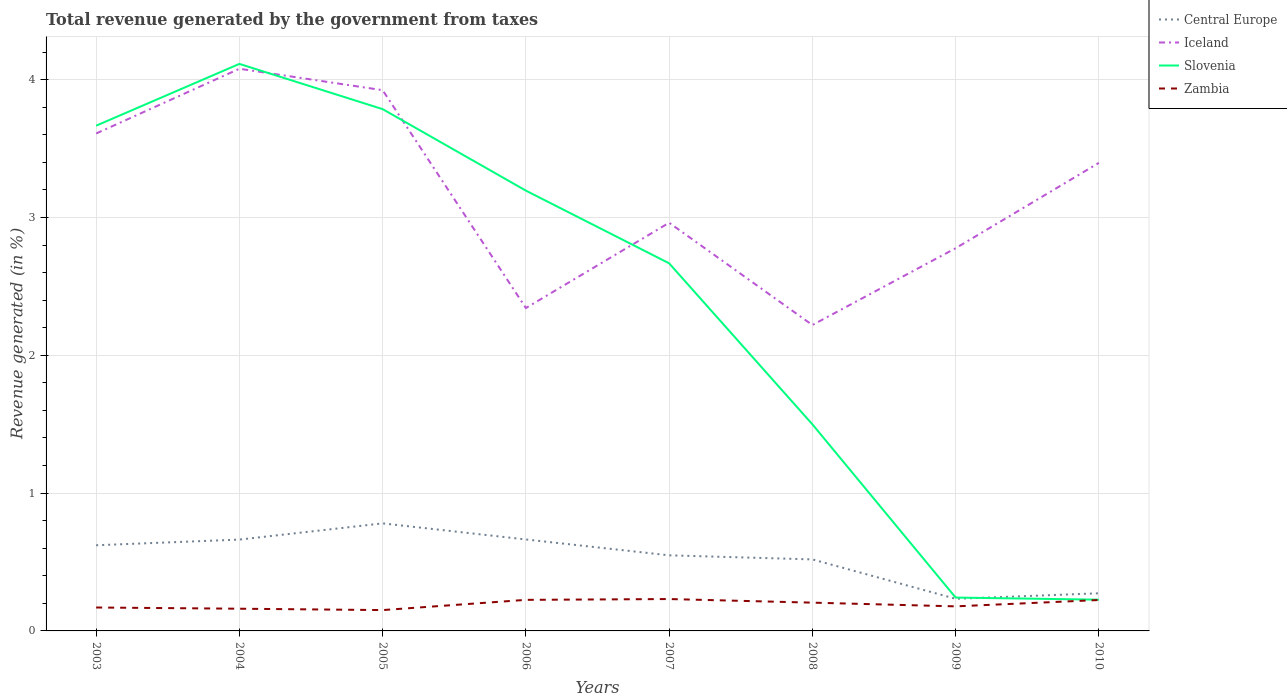Across all years, what is the maximum total revenue generated in Slovenia?
Provide a succinct answer. 0.23. What is the total total revenue generated in Iceland in the graph?
Your response must be concise. -1.05. What is the difference between the highest and the second highest total revenue generated in Slovenia?
Ensure brevity in your answer.  3.89. Is the total revenue generated in Slovenia strictly greater than the total revenue generated in Zambia over the years?
Make the answer very short. No. How many lines are there?
Your answer should be very brief. 4. What is the difference between two consecutive major ticks on the Y-axis?
Ensure brevity in your answer.  1. Does the graph contain grids?
Give a very brief answer. Yes. How many legend labels are there?
Offer a terse response. 4. How are the legend labels stacked?
Provide a succinct answer. Vertical. What is the title of the graph?
Ensure brevity in your answer.  Total revenue generated by the government from taxes. What is the label or title of the X-axis?
Provide a short and direct response. Years. What is the label or title of the Y-axis?
Give a very brief answer. Revenue generated (in %). What is the Revenue generated (in %) of Central Europe in 2003?
Your response must be concise. 0.62. What is the Revenue generated (in %) of Iceland in 2003?
Ensure brevity in your answer.  3.61. What is the Revenue generated (in %) in Slovenia in 2003?
Ensure brevity in your answer.  3.67. What is the Revenue generated (in %) in Zambia in 2003?
Give a very brief answer. 0.17. What is the Revenue generated (in %) of Central Europe in 2004?
Make the answer very short. 0.66. What is the Revenue generated (in %) of Iceland in 2004?
Give a very brief answer. 4.08. What is the Revenue generated (in %) in Slovenia in 2004?
Ensure brevity in your answer.  4.11. What is the Revenue generated (in %) of Zambia in 2004?
Offer a very short reply. 0.16. What is the Revenue generated (in %) in Central Europe in 2005?
Your answer should be compact. 0.78. What is the Revenue generated (in %) in Iceland in 2005?
Make the answer very short. 3.92. What is the Revenue generated (in %) of Slovenia in 2005?
Provide a short and direct response. 3.79. What is the Revenue generated (in %) of Zambia in 2005?
Make the answer very short. 0.15. What is the Revenue generated (in %) in Central Europe in 2006?
Keep it short and to the point. 0.66. What is the Revenue generated (in %) of Iceland in 2006?
Ensure brevity in your answer.  2.34. What is the Revenue generated (in %) in Slovenia in 2006?
Provide a short and direct response. 3.19. What is the Revenue generated (in %) of Zambia in 2006?
Your response must be concise. 0.23. What is the Revenue generated (in %) of Central Europe in 2007?
Offer a very short reply. 0.55. What is the Revenue generated (in %) of Iceland in 2007?
Offer a very short reply. 2.96. What is the Revenue generated (in %) in Slovenia in 2007?
Your response must be concise. 2.67. What is the Revenue generated (in %) in Zambia in 2007?
Offer a terse response. 0.23. What is the Revenue generated (in %) in Central Europe in 2008?
Keep it short and to the point. 0.52. What is the Revenue generated (in %) in Iceland in 2008?
Make the answer very short. 2.22. What is the Revenue generated (in %) of Slovenia in 2008?
Provide a short and direct response. 1.5. What is the Revenue generated (in %) in Zambia in 2008?
Your response must be concise. 0.21. What is the Revenue generated (in %) in Central Europe in 2009?
Ensure brevity in your answer.  0.23. What is the Revenue generated (in %) of Iceland in 2009?
Offer a very short reply. 2.78. What is the Revenue generated (in %) of Slovenia in 2009?
Give a very brief answer. 0.24. What is the Revenue generated (in %) in Zambia in 2009?
Make the answer very short. 0.18. What is the Revenue generated (in %) in Central Europe in 2010?
Your answer should be very brief. 0.27. What is the Revenue generated (in %) in Iceland in 2010?
Ensure brevity in your answer.  3.4. What is the Revenue generated (in %) of Slovenia in 2010?
Keep it short and to the point. 0.23. What is the Revenue generated (in %) of Zambia in 2010?
Keep it short and to the point. 0.22. Across all years, what is the maximum Revenue generated (in %) in Central Europe?
Offer a terse response. 0.78. Across all years, what is the maximum Revenue generated (in %) in Iceland?
Ensure brevity in your answer.  4.08. Across all years, what is the maximum Revenue generated (in %) in Slovenia?
Your answer should be very brief. 4.11. Across all years, what is the maximum Revenue generated (in %) in Zambia?
Your answer should be very brief. 0.23. Across all years, what is the minimum Revenue generated (in %) in Central Europe?
Keep it short and to the point. 0.23. Across all years, what is the minimum Revenue generated (in %) of Iceland?
Ensure brevity in your answer.  2.22. Across all years, what is the minimum Revenue generated (in %) in Slovenia?
Your answer should be very brief. 0.23. Across all years, what is the minimum Revenue generated (in %) of Zambia?
Make the answer very short. 0.15. What is the total Revenue generated (in %) in Central Europe in the graph?
Offer a very short reply. 4.3. What is the total Revenue generated (in %) of Iceland in the graph?
Offer a very short reply. 25.31. What is the total Revenue generated (in %) in Slovenia in the graph?
Ensure brevity in your answer.  19.4. What is the total Revenue generated (in %) in Zambia in the graph?
Your answer should be compact. 1.55. What is the difference between the Revenue generated (in %) in Central Europe in 2003 and that in 2004?
Make the answer very short. -0.04. What is the difference between the Revenue generated (in %) in Iceland in 2003 and that in 2004?
Offer a very short reply. -0.47. What is the difference between the Revenue generated (in %) in Slovenia in 2003 and that in 2004?
Your answer should be compact. -0.45. What is the difference between the Revenue generated (in %) in Zambia in 2003 and that in 2004?
Give a very brief answer. 0.01. What is the difference between the Revenue generated (in %) of Central Europe in 2003 and that in 2005?
Make the answer very short. -0.16. What is the difference between the Revenue generated (in %) in Iceland in 2003 and that in 2005?
Offer a terse response. -0.31. What is the difference between the Revenue generated (in %) of Slovenia in 2003 and that in 2005?
Provide a succinct answer. -0.12. What is the difference between the Revenue generated (in %) of Zambia in 2003 and that in 2005?
Give a very brief answer. 0.02. What is the difference between the Revenue generated (in %) in Central Europe in 2003 and that in 2006?
Offer a terse response. -0.04. What is the difference between the Revenue generated (in %) in Iceland in 2003 and that in 2006?
Your answer should be compact. 1.27. What is the difference between the Revenue generated (in %) in Slovenia in 2003 and that in 2006?
Your response must be concise. 0.47. What is the difference between the Revenue generated (in %) in Zambia in 2003 and that in 2006?
Make the answer very short. -0.06. What is the difference between the Revenue generated (in %) in Central Europe in 2003 and that in 2007?
Keep it short and to the point. 0.07. What is the difference between the Revenue generated (in %) of Iceland in 2003 and that in 2007?
Provide a short and direct response. 0.65. What is the difference between the Revenue generated (in %) of Slovenia in 2003 and that in 2007?
Your answer should be very brief. 1. What is the difference between the Revenue generated (in %) in Zambia in 2003 and that in 2007?
Your answer should be compact. -0.06. What is the difference between the Revenue generated (in %) in Central Europe in 2003 and that in 2008?
Ensure brevity in your answer.  0.1. What is the difference between the Revenue generated (in %) of Iceland in 2003 and that in 2008?
Make the answer very short. 1.39. What is the difference between the Revenue generated (in %) in Slovenia in 2003 and that in 2008?
Provide a succinct answer. 2.17. What is the difference between the Revenue generated (in %) in Zambia in 2003 and that in 2008?
Offer a very short reply. -0.04. What is the difference between the Revenue generated (in %) of Central Europe in 2003 and that in 2009?
Offer a very short reply. 0.39. What is the difference between the Revenue generated (in %) of Iceland in 2003 and that in 2009?
Give a very brief answer. 0.83. What is the difference between the Revenue generated (in %) in Slovenia in 2003 and that in 2009?
Make the answer very short. 3.42. What is the difference between the Revenue generated (in %) of Zambia in 2003 and that in 2009?
Keep it short and to the point. -0.01. What is the difference between the Revenue generated (in %) in Central Europe in 2003 and that in 2010?
Give a very brief answer. 0.35. What is the difference between the Revenue generated (in %) of Iceland in 2003 and that in 2010?
Your answer should be very brief. 0.21. What is the difference between the Revenue generated (in %) in Slovenia in 2003 and that in 2010?
Your response must be concise. 3.44. What is the difference between the Revenue generated (in %) in Zambia in 2003 and that in 2010?
Your answer should be compact. -0.05. What is the difference between the Revenue generated (in %) of Central Europe in 2004 and that in 2005?
Make the answer very short. -0.12. What is the difference between the Revenue generated (in %) in Iceland in 2004 and that in 2005?
Your answer should be very brief. 0.16. What is the difference between the Revenue generated (in %) in Slovenia in 2004 and that in 2005?
Offer a very short reply. 0.33. What is the difference between the Revenue generated (in %) in Zambia in 2004 and that in 2005?
Your response must be concise. 0.01. What is the difference between the Revenue generated (in %) in Central Europe in 2004 and that in 2006?
Offer a terse response. -0. What is the difference between the Revenue generated (in %) of Iceland in 2004 and that in 2006?
Provide a short and direct response. 1.74. What is the difference between the Revenue generated (in %) of Slovenia in 2004 and that in 2006?
Your response must be concise. 0.92. What is the difference between the Revenue generated (in %) of Zambia in 2004 and that in 2006?
Offer a terse response. -0.06. What is the difference between the Revenue generated (in %) of Central Europe in 2004 and that in 2007?
Give a very brief answer. 0.11. What is the difference between the Revenue generated (in %) of Iceland in 2004 and that in 2007?
Provide a short and direct response. 1.12. What is the difference between the Revenue generated (in %) of Slovenia in 2004 and that in 2007?
Keep it short and to the point. 1.45. What is the difference between the Revenue generated (in %) in Zambia in 2004 and that in 2007?
Your answer should be very brief. -0.07. What is the difference between the Revenue generated (in %) of Central Europe in 2004 and that in 2008?
Make the answer very short. 0.14. What is the difference between the Revenue generated (in %) of Iceland in 2004 and that in 2008?
Offer a very short reply. 1.86. What is the difference between the Revenue generated (in %) of Slovenia in 2004 and that in 2008?
Make the answer very short. 2.62. What is the difference between the Revenue generated (in %) of Zambia in 2004 and that in 2008?
Make the answer very short. -0.04. What is the difference between the Revenue generated (in %) of Central Europe in 2004 and that in 2009?
Your response must be concise. 0.43. What is the difference between the Revenue generated (in %) of Iceland in 2004 and that in 2009?
Give a very brief answer. 1.3. What is the difference between the Revenue generated (in %) of Slovenia in 2004 and that in 2009?
Make the answer very short. 3.87. What is the difference between the Revenue generated (in %) of Zambia in 2004 and that in 2009?
Provide a succinct answer. -0.02. What is the difference between the Revenue generated (in %) in Central Europe in 2004 and that in 2010?
Your response must be concise. 0.39. What is the difference between the Revenue generated (in %) in Iceland in 2004 and that in 2010?
Offer a very short reply. 0.68. What is the difference between the Revenue generated (in %) in Slovenia in 2004 and that in 2010?
Offer a terse response. 3.89. What is the difference between the Revenue generated (in %) of Zambia in 2004 and that in 2010?
Keep it short and to the point. -0.06. What is the difference between the Revenue generated (in %) of Central Europe in 2005 and that in 2006?
Ensure brevity in your answer.  0.12. What is the difference between the Revenue generated (in %) of Iceland in 2005 and that in 2006?
Your answer should be very brief. 1.58. What is the difference between the Revenue generated (in %) of Slovenia in 2005 and that in 2006?
Provide a short and direct response. 0.59. What is the difference between the Revenue generated (in %) in Zambia in 2005 and that in 2006?
Your response must be concise. -0.07. What is the difference between the Revenue generated (in %) in Central Europe in 2005 and that in 2007?
Provide a short and direct response. 0.23. What is the difference between the Revenue generated (in %) of Iceland in 2005 and that in 2007?
Your answer should be very brief. 0.96. What is the difference between the Revenue generated (in %) of Slovenia in 2005 and that in 2007?
Provide a succinct answer. 1.12. What is the difference between the Revenue generated (in %) of Zambia in 2005 and that in 2007?
Provide a short and direct response. -0.08. What is the difference between the Revenue generated (in %) of Central Europe in 2005 and that in 2008?
Provide a short and direct response. 0.26. What is the difference between the Revenue generated (in %) of Iceland in 2005 and that in 2008?
Ensure brevity in your answer.  1.7. What is the difference between the Revenue generated (in %) of Slovenia in 2005 and that in 2008?
Give a very brief answer. 2.29. What is the difference between the Revenue generated (in %) of Zambia in 2005 and that in 2008?
Make the answer very short. -0.05. What is the difference between the Revenue generated (in %) of Central Europe in 2005 and that in 2009?
Your response must be concise. 0.55. What is the difference between the Revenue generated (in %) in Iceland in 2005 and that in 2009?
Your response must be concise. 1.15. What is the difference between the Revenue generated (in %) in Slovenia in 2005 and that in 2009?
Your answer should be very brief. 3.54. What is the difference between the Revenue generated (in %) of Zambia in 2005 and that in 2009?
Your answer should be compact. -0.03. What is the difference between the Revenue generated (in %) in Central Europe in 2005 and that in 2010?
Ensure brevity in your answer.  0.51. What is the difference between the Revenue generated (in %) in Iceland in 2005 and that in 2010?
Keep it short and to the point. 0.53. What is the difference between the Revenue generated (in %) in Slovenia in 2005 and that in 2010?
Make the answer very short. 3.56. What is the difference between the Revenue generated (in %) in Zambia in 2005 and that in 2010?
Provide a short and direct response. -0.07. What is the difference between the Revenue generated (in %) of Central Europe in 2006 and that in 2007?
Your answer should be compact. 0.12. What is the difference between the Revenue generated (in %) of Iceland in 2006 and that in 2007?
Ensure brevity in your answer.  -0.62. What is the difference between the Revenue generated (in %) of Slovenia in 2006 and that in 2007?
Give a very brief answer. 0.53. What is the difference between the Revenue generated (in %) in Zambia in 2006 and that in 2007?
Your response must be concise. -0.01. What is the difference between the Revenue generated (in %) of Central Europe in 2006 and that in 2008?
Your answer should be compact. 0.14. What is the difference between the Revenue generated (in %) in Iceland in 2006 and that in 2008?
Your answer should be very brief. 0.12. What is the difference between the Revenue generated (in %) in Slovenia in 2006 and that in 2008?
Your answer should be very brief. 1.7. What is the difference between the Revenue generated (in %) of Zambia in 2006 and that in 2008?
Give a very brief answer. 0.02. What is the difference between the Revenue generated (in %) of Central Europe in 2006 and that in 2009?
Offer a very short reply. 0.43. What is the difference between the Revenue generated (in %) of Iceland in 2006 and that in 2009?
Your response must be concise. -0.43. What is the difference between the Revenue generated (in %) in Slovenia in 2006 and that in 2009?
Offer a very short reply. 2.95. What is the difference between the Revenue generated (in %) in Zambia in 2006 and that in 2009?
Offer a very short reply. 0.05. What is the difference between the Revenue generated (in %) of Central Europe in 2006 and that in 2010?
Your answer should be compact. 0.39. What is the difference between the Revenue generated (in %) of Iceland in 2006 and that in 2010?
Make the answer very short. -1.05. What is the difference between the Revenue generated (in %) in Slovenia in 2006 and that in 2010?
Give a very brief answer. 2.97. What is the difference between the Revenue generated (in %) of Zambia in 2006 and that in 2010?
Provide a short and direct response. 0. What is the difference between the Revenue generated (in %) of Central Europe in 2007 and that in 2008?
Your answer should be very brief. 0.03. What is the difference between the Revenue generated (in %) of Iceland in 2007 and that in 2008?
Give a very brief answer. 0.74. What is the difference between the Revenue generated (in %) in Slovenia in 2007 and that in 2008?
Keep it short and to the point. 1.17. What is the difference between the Revenue generated (in %) in Zambia in 2007 and that in 2008?
Give a very brief answer. 0.03. What is the difference between the Revenue generated (in %) of Central Europe in 2007 and that in 2009?
Give a very brief answer. 0.32. What is the difference between the Revenue generated (in %) of Iceland in 2007 and that in 2009?
Your answer should be very brief. 0.18. What is the difference between the Revenue generated (in %) in Slovenia in 2007 and that in 2009?
Give a very brief answer. 2.43. What is the difference between the Revenue generated (in %) of Zambia in 2007 and that in 2009?
Ensure brevity in your answer.  0.05. What is the difference between the Revenue generated (in %) in Central Europe in 2007 and that in 2010?
Your response must be concise. 0.28. What is the difference between the Revenue generated (in %) in Iceland in 2007 and that in 2010?
Make the answer very short. -0.43. What is the difference between the Revenue generated (in %) of Slovenia in 2007 and that in 2010?
Your answer should be very brief. 2.44. What is the difference between the Revenue generated (in %) in Zambia in 2007 and that in 2010?
Offer a terse response. 0.01. What is the difference between the Revenue generated (in %) in Central Europe in 2008 and that in 2009?
Your response must be concise. 0.29. What is the difference between the Revenue generated (in %) of Iceland in 2008 and that in 2009?
Give a very brief answer. -0.56. What is the difference between the Revenue generated (in %) of Slovenia in 2008 and that in 2009?
Your response must be concise. 1.26. What is the difference between the Revenue generated (in %) of Zambia in 2008 and that in 2009?
Ensure brevity in your answer.  0.03. What is the difference between the Revenue generated (in %) in Central Europe in 2008 and that in 2010?
Offer a very short reply. 0.25. What is the difference between the Revenue generated (in %) in Iceland in 2008 and that in 2010?
Ensure brevity in your answer.  -1.18. What is the difference between the Revenue generated (in %) in Slovenia in 2008 and that in 2010?
Offer a terse response. 1.27. What is the difference between the Revenue generated (in %) in Zambia in 2008 and that in 2010?
Give a very brief answer. -0.02. What is the difference between the Revenue generated (in %) of Central Europe in 2009 and that in 2010?
Your answer should be very brief. -0.04. What is the difference between the Revenue generated (in %) of Iceland in 2009 and that in 2010?
Your answer should be very brief. -0.62. What is the difference between the Revenue generated (in %) of Slovenia in 2009 and that in 2010?
Offer a terse response. 0.02. What is the difference between the Revenue generated (in %) of Zambia in 2009 and that in 2010?
Keep it short and to the point. -0.05. What is the difference between the Revenue generated (in %) of Central Europe in 2003 and the Revenue generated (in %) of Iceland in 2004?
Give a very brief answer. -3.46. What is the difference between the Revenue generated (in %) of Central Europe in 2003 and the Revenue generated (in %) of Slovenia in 2004?
Offer a very short reply. -3.49. What is the difference between the Revenue generated (in %) of Central Europe in 2003 and the Revenue generated (in %) of Zambia in 2004?
Offer a very short reply. 0.46. What is the difference between the Revenue generated (in %) of Iceland in 2003 and the Revenue generated (in %) of Slovenia in 2004?
Provide a succinct answer. -0.51. What is the difference between the Revenue generated (in %) in Iceland in 2003 and the Revenue generated (in %) in Zambia in 2004?
Your answer should be compact. 3.45. What is the difference between the Revenue generated (in %) of Slovenia in 2003 and the Revenue generated (in %) of Zambia in 2004?
Offer a terse response. 3.5. What is the difference between the Revenue generated (in %) of Central Europe in 2003 and the Revenue generated (in %) of Iceland in 2005?
Keep it short and to the point. -3.3. What is the difference between the Revenue generated (in %) of Central Europe in 2003 and the Revenue generated (in %) of Slovenia in 2005?
Provide a short and direct response. -3.16. What is the difference between the Revenue generated (in %) of Central Europe in 2003 and the Revenue generated (in %) of Zambia in 2005?
Offer a very short reply. 0.47. What is the difference between the Revenue generated (in %) in Iceland in 2003 and the Revenue generated (in %) in Slovenia in 2005?
Give a very brief answer. -0.18. What is the difference between the Revenue generated (in %) in Iceland in 2003 and the Revenue generated (in %) in Zambia in 2005?
Ensure brevity in your answer.  3.46. What is the difference between the Revenue generated (in %) of Slovenia in 2003 and the Revenue generated (in %) of Zambia in 2005?
Provide a succinct answer. 3.51. What is the difference between the Revenue generated (in %) in Central Europe in 2003 and the Revenue generated (in %) in Iceland in 2006?
Provide a short and direct response. -1.72. What is the difference between the Revenue generated (in %) of Central Europe in 2003 and the Revenue generated (in %) of Slovenia in 2006?
Make the answer very short. -2.57. What is the difference between the Revenue generated (in %) in Central Europe in 2003 and the Revenue generated (in %) in Zambia in 2006?
Keep it short and to the point. 0.4. What is the difference between the Revenue generated (in %) in Iceland in 2003 and the Revenue generated (in %) in Slovenia in 2006?
Provide a short and direct response. 0.41. What is the difference between the Revenue generated (in %) in Iceland in 2003 and the Revenue generated (in %) in Zambia in 2006?
Keep it short and to the point. 3.38. What is the difference between the Revenue generated (in %) of Slovenia in 2003 and the Revenue generated (in %) of Zambia in 2006?
Offer a terse response. 3.44. What is the difference between the Revenue generated (in %) of Central Europe in 2003 and the Revenue generated (in %) of Iceland in 2007?
Your answer should be compact. -2.34. What is the difference between the Revenue generated (in %) in Central Europe in 2003 and the Revenue generated (in %) in Slovenia in 2007?
Make the answer very short. -2.05. What is the difference between the Revenue generated (in %) of Central Europe in 2003 and the Revenue generated (in %) of Zambia in 2007?
Ensure brevity in your answer.  0.39. What is the difference between the Revenue generated (in %) of Iceland in 2003 and the Revenue generated (in %) of Slovenia in 2007?
Your response must be concise. 0.94. What is the difference between the Revenue generated (in %) in Iceland in 2003 and the Revenue generated (in %) in Zambia in 2007?
Your answer should be very brief. 3.38. What is the difference between the Revenue generated (in %) of Slovenia in 2003 and the Revenue generated (in %) of Zambia in 2007?
Keep it short and to the point. 3.43. What is the difference between the Revenue generated (in %) in Central Europe in 2003 and the Revenue generated (in %) in Iceland in 2008?
Give a very brief answer. -1.6. What is the difference between the Revenue generated (in %) of Central Europe in 2003 and the Revenue generated (in %) of Slovenia in 2008?
Your answer should be compact. -0.88. What is the difference between the Revenue generated (in %) in Central Europe in 2003 and the Revenue generated (in %) in Zambia in 2008?
Offer a terse response. 0.42. What is the difference between the Revenue generated (in %) of Iceland in 2003 and the Revenue generated (in %) of Slovenia in 2008?
Offer a terse response. 2.11. What is the difference between the Revenue generated (in %) in Iceland in 2003 and the Revenue generated (in %) in Zambia in 2008?
Your response must be concise. 3.4. What is the difference between the Revenue generated (in %) of Slovenia in 2003 and the Revenue generated (in %) of Zambia in 2008?
Provide a succinct answer. 3.46. What is the difference between the Revenue generated (in %) in Central Europe in 2003 and the Revenue generated (in %) in Iceland in 2009?
Ensure brevity in your answer.  -2.15. What is the difference between the Revenue generated (in %) in Central Europe in 2003 and the Revenue generated (in %) in Slovenia in 2009?
Your answer should be very brief. 0.38. What is the difference between the Revenue generated (in %) in Central Europe in 2003 and the Revenue generated (in %) in Zambia in 2009?
Your response must be concise. 0.44. What is the difference between the Revenue generated (in %) in Iceland in 2003 and the Revenue generated (in %) in Slovenia in 2009?
Your answer should be compact. 3.37. What is the difference between the Revenue generated (in %) of Iceland in 2003 and the Revenue generated (in %) of Zambia in 2009?
Your answer should be very brief. 3.43. What is the difference between the Revenue generated (in %) in Slovenia in 2003 and the Revenue generated (in %) in Zambia in 2009?
Ensure brevity in your answer.  3.49. What is the difference between the Revenue generated (in %) in Central Europe in 2003 and the Revenue generated (in %) in Iceland in 2010?
Offer a very short reply. -2.77. What is the difference between the Revenue generated (in %) of Central Europe in 2003 and the Revenue generated (in %) of Slovenia in 2010?
Ensure brevity in your answer.  0.39. What is the difference between the Revenue generated (in %) in Central Europe in 2003 and the Revenue generated (in %) in Zambia in 2010?
Offer a very short reply. 0.4. What is the difference between the Revenue generated (in %) of Iceland in 2003 and the Revenue generated (in %) of Slovenia in 2010?
Your answer should be compact. 3.38. What is the difference between the Revenue generated (in %) in Iceland in 2003 and the Revenue generated (in %) in Zambia in 2010?
Give a very brief answer. 3.38. What is the difference between the Revenue generated (in %) in Slovenia in 2003 and the Revenue generated (in %) in Zambia in 2010?
Provide a short and direct response. 3.44. What is the difference between the Revenue generated (in %) of Central Europe in 2004 and the Revenue generated (in %) of Iceland in 2005?
Your response must be concise. -3.26. What is the difference between the Revenue generated (in %) of Central Europe in 2004 and the Revenue generated (in %) of Slovenia in 2005?
Offer a terse response. -3.12. What is the difference between the Revenue generated (in %) of Central Europe in 2004 and the Revenue generated (in %) of Zambia in 2005?
Make the answer very short. 0.51. What is the difference between the Revenue generated (in %) in Iceland in 2004 and the Revenue generated (in %) in Slovenia in 2005?
Provide a succinct answer. 0.29. What is the difference between the Revenue generated (in %) of Iceland in 2004 and the Revenue generated (in %) of Zambia in 2005?
Make the answer very short. 3.93. What is the difference between the Revenue generated (in %) of Slovenia in 2004 and the Revenue generated (in %) of Zambia in 2005?
Offer a terse response. 3.96. What is the difference between the Revenue generated (in %) of Central Europe in 2004 and the Revenue generated (in %) of Iceland in 2006?
Provide a succinct answer. -1.68. What is the difference between the Revenue generated (in %) of Central Europe in 2004 and the Revenue generated (in %) of Slovenia in 2006?
Your answer should be compact. -2.53. What is the difference between the Revenue generated (in %) in Central Europe in 2004 and the Revenue generated (in %) in Zambia in 2006?
Your answer should be very brief. 0.44. What is the difference between the Revenue generated (in %) in Iceland in 2004 and the Revenue generated (in %) in Slovenia in 2006?
Ensure brevity in your answer.  0.88. What is the difference between the Revenue generated (in %) of Iceland in 2004 and the Revenue generated (in %) of Zambia in 2006?
Provide a short and direct response. 3.85. What is the difference between the Revenue generated (in %) of Slovenia in 2004 and the Revenue generated (in %) of Zambia in 2006?
Your answer should be very brief. 3.89. What is the difference between the Revenue generated (in %) of Central Europe in 2004 and the Revenue generated (in %) of Iceland in 2007?
Ensure brevity in your answer.  -2.3. What is the difference between the Revenue generated (in %) of Central Europe in 2004 and the Revenue generated (in %) of Slovenia in 2007?
Ensure brevity in your answer.  -2. What is the difference between the Revenue generated (in %) in Central Europe in 2004 and the Revenue generated (in %) in Zambia in 2007?
Your answer should be very brief. 0.43. What is the difference between the Revenue generated (in %) of Iceland in 2004 and the Revenue generated (in %) of Slovenia in 2007?
Your response must be concise. 1.41. What is the difference between the Revenue generated (in %) in Iceland in 2004 and the Revenue generated (in %) in Zambia in 2007?
Offer a terse response. 3.85. What is the difference between the Revenue generated (in %) of Slovenia in 2004 and the Revenue generated (in %) of Zambia in 2007?
Offer a terse response. 3.88. What is the difference between the Revenue generated (in %) of Central Europe in 2004 and the Revenue generated (in %) of Iceland in 2008?
Provide a succinct answer. -1.56. What is the difference between the Revenue generated (in %) in Central Europe in 2004 and the Revenue generated (in %) in Slovenia in 2008?
Ensure brevity in your answer.  -0.84. What is the difference between the Revenue generated (in %) in Central Europe in 2004 and the Revenue generated (in %) in Zambia in 2008?
Your answer should be very brief. 0.46. What is the difference between the Revenue generated (in %) in Iceland in 2004 and the Revenue generated (in %) in Slovenia in 2008?
Give a very brief answer. 2.58. What is the difference between the Revenue generated (in %) in Iceland in 2004 and the Revenue generated (in %) in Zambia in 2008?
Your response must be concise. 3.87. What is the difference between the Revenue generated (in %) in Slovenia in 2004 and the Revenue generated (in %) in Zambia in 2008?
Offer a terse response. 3.91. What is the difference between the Revenue generated (in %) of Central Europe in 2004 and the Revenue generated (in %) of Iceland in 2009?
Your answer should be very brief. -2.11. What is the difference between the Revenue generated (in %) in Central Europe in 2004 and the Revenue generated (in %) in Slovenia in 2009?
Your answer should be compact. 0.42. What is the difference between the Revenue generated (in %) of Central Europe in 2004 and the Revenue generated (in %) of Zambia in 2009?
Provide a succinct answer. 0.48. What is the difference between the Revenue generated (in %) in Iceland in 2004 and the Revenue generated (in %) in Slovenia in 2009?
Your response must be concise. 3.84. What is the difference between the Revenue generated (in %) in Iceland in 2004 and the Revenue generated (in %) in Zambia in 2009?
Your answer should be compact. 3.9. What is the difference between the Revenue generated (in %) in Slovenia in 2004 and the Revenue generated (in %) in Zambia in 2009?
Provide a succinct answer. 3.94. What is the difference between the Revenue generated (in %) in Central Europe in 2004 and the Revenue generated (in %) in Iceland in 2010?
Your answer should be compact. -2.73. What is the difference between the Revenue generated (in %) in Central Europe in 2004 and the Revenue generated (in %) in Slovenia in 2010?
Your answer should be very brief. 0.44. What is the difference between the Revenue generated (in %) in Central Europe in 2004 and the Revenue generated (in %) in Zambia in 2010?
Offer a very short reply. 0.44. What is the difference between the Revenue generated (in %) in Iceland in 2004 and the Revenue generated (in %) in Slovenia in 2010?
Your answer should be very brief. 3.85. What is the difference between the Revenue generated (in %) of Iceland in 2004 and the Revenue generated (in %) of Zambia in 2010?
Your answer should be very brief. 3.85. What is the difference between the Revenue generated (in %) of Slovenia in 2004 and the Revenue generated (in %) of Zambia in 2010?
Your answer should be very brief. 3.89. What is the difference between the Revenue generated (in %) of Central Europe in 2005 and the Revenue generated (in %) of Iceland in 2006?
Provide a short and direct response. -1.56. What is the difference between the Revenue generated (in %) of Central Europe in 2005 and the Revenue generated (in %) of Slovenia in 2006?
Provide a short and direct response. -2.41. What is the difference between the Revenue generated (in %) in Central Europe in 2005 and the Revenue generated (in %) in Zambia in 2006?
Your answer should be compact. 0.55. What is the difference between the Revenue generated (in %) in Iceland in 2005 and the Revenue generated (in %) in Slovenia in 2006?
Your response must be concise. 0.73. What is the difference between the Revenue generated (in %) of Iceland in 2005 and the Revenue generated (in %) of Zambia in 2006?
Offer a very short reply. 3.7. What is the difference between the Revenue generated (in %) of Slovenia in 2005 and the Revenue generated (in %) of Zambia in 2006?
Give a very brief answer. 3.56. What is the difference between the Revenue generated (in %) of Central Europe in 2005 and the Revenue generated (in %) of Iceland in 2007?
Your answer should be very brief. -2.18. What is the difference between the Revenue generated (in %) in Central Europe in 2005 and the Revenue generated (in %) in Slovenia in 2007?
Your response must be concise. -1.89. What is the difference between the Revenue generated (in %) in Central Europe in 2005 and the Revenue generated (in %) in Zambia in 2007?
Keep it short and to the point. 0.55. What is the difference between the Revenue generated (in %) in Iceland in 2005 and the Revenue generated (in %) in Slovenia in 2007?
Offer a terse response. 1.26. What is the difference between the Revenue generated (in %) of Iceland in 2005 and the Revenue generated (in %) of Zambia in 2007?
Your response must be concise. 3.69. What is the difference between the Revenue generated (in %) of Slovenia in 2005 and the Revenue generated (in %) of Zambia in 2007?
Your response must be concise. 3.55. What is the difference between the Revenue generated (in %) of Central Europe in 2005 and the Revenue generated (in %) of Iceland in 2008?
Offer a terse response. -1.44. What is the difference between the Revenue generated (in %) of Central Europe in 2005 and the Revenue generated (in %) of Slovenia in 2008?
Provide a succinct answer. -0.72. What is the difference between the Revenue generated (in %) in Central Europe in 2005 and the Revenue generated (in %) in Zambia in 2008?
Your response must be concise. 0.58. What is the difference between the Revenue generated (in %) of Iceland in 2005 and the Revenue generated (in %) of Slovenia in 2008?
Offer a very short reply. 2.42. What is the difference between the Revenue generated (in %) in Iceland in 2005 and the Revenue generated (in %) in Zambia in 2008?
Your answer should be compact. 3.72. What is the difference between the Revenue generated (in %) in Slovenia in 2005 and the Revenue generated (in %) in Zambia in 2008?
Keep it short and to the point. 3.58. What is the difference between the Revenue generated (in %) in Central Europe in 2005 and the Revenue generated (in %) in Iceland in 2009?
Provide a short and direct response. -2. What is the difference between the Revenue generated (in %) in Central Europe in 2005 and the Revenue generated (in %) in Slovenia in 2009?
Keep it short and to the point. 0.54. What is the difference between the Revenue generated (in %) in Central Europe in 2005 and the Revenue generated (in %) in Zambia in 2009?
Provide a succinct answer. 0.6. What is the difference between the Revenue generated (in %) in Iceland in 2005 and the Revenue generated (in %) in Slovenia in 2009?
Provide a succinct answer. 3.68. What is the difference between the Revenue generated (in %) of Iceland in 2005 and the Revenue generated (in %) of Zambia in 2009?
Provide a succinct answer. 3.75. What is the difference between the Revenue generated (in %) of Slovenia in 2005 and the Revenue generated (in %) of Zambia in 2009?
Give a very brief answer. 3.61. What is the difference between the Revenue generated (in %) in Central Europe in 2005 and the Revenue generated (in %) in Iceland in 2010?
Provide a short and direct response. -2.62. What is the difference between the Revenue generated (in %) of Central Europe in 2005 and the Revenue generated (in %) of Slovenia in 2010?
Your response must be concise. 0.55. What is the difference between the Revenue generated (in %) of Central Europe in 2005 and the Revenue generated (in %) of Zambia in 2010?
Your answer should be very brief. 0.56. What is the difference between the Revenue generated (in %) in Iceland in 2005 and the Revenue generated (in %) in Slovenia in 2010?
Your answer should be compact. 3.7. What is the difference between the Revenue generated (in %) in Iceland in 2005 and the Revenue generated (in %) in Zambia in 2010?
Provide a short and direct response. 3.7. What is the difference between the Revenue generated (in %) of Slovenia in 2005 and the Revenue generated (in %) of Zambia in 2010?
Offer a terse response. 3.56. What is the difference between the Revenue generated (in %) of Central Europe in 2006 and the Revenue generated (in %) of Iceland in 2007?
Your answer should be very brief. -2.3. What is the difference between the Revenue generated (in %) of Central Europe in 2006 and the Revenue generated (in %) of Slovenia in 2007?
Your response must be concise. -2. What is the difference between the Revenue generated (in %) of Central Europe in 2006 and the Revenue generated (in %) of Zambia in 2007?
Your answer should be compact. 0.43. What is the difference between the Revenue generated (in %) in Iceland in 2006 and the Revenue generated (in %) in Slovenia in 2007?
Give a very brief answer. -0.32. What is the difference between the Revenue generated (in %) in Iceland in 2006 and the Revenue generated (in %) in Zambia in 2007?
Offer a terse response. 2.11. What is the difference between the Revenue generated (in %) in Slovenia in 2006 and the Revenue generated (in %) in Zambia in 2007?
Your response must be concise. 2.96. What is the difference between the Revenue generated (in %) of Central Europe in 2006 and the Revenue generated (in %) of Iceland in 2008?
Your answer should be compact. -1.56. What is the difference between the Revenue generated (in %) in Central Europe in 2006 and the Revenue generated (in %) in Slovenia in 2008?
Your answer should be very brief. -0.84. What is the difference between the Revenue generated (in %) in Central Europe in 2006 and the Revenue generated (in %) in Zambia in 2008?
Offer a terse response. 0.46. What is the difference between the Revenue generated (in %) in Iceland in 2006 and the Revenue generated (in %) in Slovenia in 2008?
Your answer should be compact. 0.84. What is the difference between the Revenue generated (in %) of Iceland in 2006 and the Revenue generated (in %) of Zambia in 2008?
Provide a short and direct response. 2.14. What is the difference between the Revenue generated (in %) of Slovenia in 2006 and the Revenue generated (in %) of Zambia in 2008?
Offer a very short reply. 2.99. What is the difference between the Revenue generated (in %) in Central Europe in 2006 and the Revenue generated (in %) in Iceland in 2009?
Give a very brief answer. -2.11. What is the difference between the Revenue generated (in %) of Central Europe in 2006 and the Revenue generated (in %) of Slovenia in 2009?
Give a very brief answer. 0.42. What is the difference between the Revenue generated (in %) of Central Europe in 2006 and the Revenue generated (in %) of Zambia in 2009?
Provide a succinct answer. 0.49. What is the difference between the Revenue generated (in %) in Iceland in 2006 and the Revenue generated (in %) in Slovenia in 2009?
Offer a terse response. 2.1. What is the difference between the Revenue generated (in %) in Iceland in 2006 and the Revenue generated (in %) in Zambia in 2009?
Give a very brief answer. 2.16. What is the difference between the Revenue generated (in %) of Slovenia in 2006 and the Revenue generated (in %) of Zambia in 2009?
Ensure brevity in your answer.  3.02. What is the difference between the Revenue generated (in %) in Central Europe in 2006 and the Revenue generated (in %) in Iceland in 2010?
Provide a succinct answer. -2.73. What is the difference between the Revenue generated (in %) of Central Europe in 2006 and the Revenue generated (in %) of Slovenia in 2010?
Provide a short and direct response. 0.44. What is the difference between the Revenue generated (in %) of Central Europe in 2006 and the Revenue generated (in %) of Zambia in 2010?
Your answer should be compact. 0.44. What is the difference between the Revenue generated (in %) of Iceland in 2006 and the Revenue generated (in %) of Slovenia in 2010?
Your answer should be compact. 2.12. What is the difference between the Revenue generated (in %) of Iceland in 2006 and the Revenue generated (in %) of Zambia in 2010?
Offer a terse response. 2.12. What is the difference between the Revenue generated (in %) in Slovenia in 2006 and the Revenue generated (in %) in Zambia in 2010?
Offer a terse response. 2.97. What is the difference between the Revenue generated (in %) of Central Europe in 2007 and the Revenue generated (in %) of Iceland in 2008?
Ensure brevity in your answer.  -1.67. What is the difference between the Revenue generated (in %) in Central Europe in 2007 and the Revenue generated (in %) in Slovenia in 2008?
Your response must be concise. -0.95. What is the difference between the Revenue generated (in %) in Central Europe in 2007 and the Revenue generated (in %) in Zambia in 2008?
Keep it short and to the point. 0.34. What is the difference between the Revenue generated (in %) in Iceland in 2007 and the Revenue generated (in %) in Slovenia in 2008?
Give a very brief answer. 1.46. What is the difference between the Revenue generated (in %) of Iceland in 2007 and the Revenue generated (in %) of Zambia in 2008?
Your answer should be compact. 2.76. What is the difference between the Revenue generated (in %) of Slovenia in 2007 and the Revenue generated (in %) of Zambia in 2008?
Offer a terse response. 2.46. What is the difference between the Revenue generated (in %) in Central Europe in 2007 and the Revenue generated (in %) in Iceland in 2009?
Your answer should be very brief. -2.23. What is the difference between the Revenue generated (in %) in Central Europe in 2007 and the Revenue generated (in %) in Slovenia in 2009?
Your answer should be compact. 0.31. What is the difference between the Revenue generated (in %) of Central Europe in 2007 and the Revenue generated (in %) of Zambia in 2009?
Keep it short and to the point. 0.37. What is the difference between the Revenue generated (in %) of Iceland in 2007 and the Revenue generated (in %) of Slovenia in 2009?
Ensure brevity in your answer.  2.72. What is the difference between the Revenue generated (in %) of Iceland in 2007 and the Revenue generated (in %) of Zambia in 2009?
Offer a terse response. 2.78. What is the difference between the Revenue generated (in %) of Slovenia in 2007 and the Revenue generated (in %) of Zambia in 2009?
Keep it short and to the point. 2.49. What is the difference between the Revenue generated (in %) of Central Europe in 2007 and the Revenue generated (in %) of Iceland in 2010?
Make the answer very short. -2.85. What is the difference between the Revenue generated (in %) in Central Europe in 2007 and the Revenue generated (in %) in Slovenia in 2010?
Your response must be concise. 0.32. What is the difference between the Revenue generated (in %) of Central Europe in 2007 and the Revenue generated (in %) of Zambia in 2010?
Provide a short and direct response. 0.32. What is the difference between the Revenue generated (in %) in Iceland in 2007 and the Revenue generated (in %) in Slovenia in 2010?
Make the answer very short. 2.73. What is the difference between the Revenue generated (in %) of Iceland in 2007 and the Revenue generated (in %) of Zambia in 2010?
Give a very brief answer. 2.74. What is the difference between the Revenue generated (in %) in Slovenia in 2007 and the Revenue generated (in %) in Zambia in 2010?
Offer a terse response. 2.44. What is the difference between the Revenue generated (in %) in Central Europe in 2008 and the Revenue generated (in %) in Iceland in 2009?
Your answer should be very brief. -2.26. What is the difference between the Revenue generated (in %) in Central Europe in 2008 and the Revenue generated (in %) in Slovenia in 2009?
Your answer should be compact. 0.28. What is the difference between the Revenue generated (in %) of Central Europe in 2008 and the Revenue generated (in %) of Zambia in 2009?
Keep it short and to the point. 0.34. What is the difference between the Revenue generated (in %) of Iceland in 2008 and the Revenue generated (in %) of Slovenia in 2009?
Provide a short and direct response. 1.98. What is the difference between the Revenue generated (in %) in Iceland in 2008 and the Revenue generated (in %) in Zambia in 2009?
Offer a very short reply. 2.04. What is the difference between the Revenue generated (in %) of Slovenia in 2008 and the Revenue generated (in %) of Zambia in 2009?
Offer a terse response. 1.32. What is the difference between the Revenue generated (in %) of Central Europe in 2008 and the Revenue generated (in %) of Iceland in 2010?
Offer a terse response. -2.88. What is the difference between the Revenue generated (in %) in Central Europe in 2008 and the Revenue generated (in %) in Slovenia in 2010?
Your answer should be compact. 0.29. What is the difference between the Revenue generated (in %) of Central Europe in 2008 and the Revenue generated (in %) of Zambia in 2010?
Give a very brief answer. 0.29. What is the difference between the Revenue generated (in %) of Iceland in 2008 and the Revenue generated (in %) of Slovenia in 2010?
Provide a succinct answer. 1.99. What is the difference between the Revenue generated (in %) in Iceland in 2008 and the Revenue generated (in %) in Zambia in 2010?
Your response must be concise. 2. What is the difference between the Revenue generated (in %) in Slovenia in 2008 and the Revenue generated (in %) in Zambia in 2010?
Provide a succinct answer. 1.27. What is the difference between the Revenue generated (in %) of Central Europe in 2009 and the Revenue generated (in %) of Iceland in 2010?
Your answer should be very brief. -3.16. What is the difference between the Revenue generated (in %) of Central Europe in 2009 and the Revenue generated (in %) of Slovenia in 2010?
Your answer should be compact. 0.01. What is the difference between the Revenue generated (in %) in Central Europe in 2009 and the Revenue generated (in %) in Zambia in 2010?
Offer a very short reply. 0.01. What is the difference between the Revenue generated (in %) in Iceland in 2009 and the Revenue generated (in %) in Slovenia in 2010?
Make the answer very short. 2.55. What is the difference between the Revenue generated (in %) of Iceland in 2009 and the Revenue generated (in %) of Zambia in 2010?
Provide a succinct answer. 2.55. What is the difference between the Revenue generated (in %) of Slovenia in 2009 and the Revenue generated (in %) of Zambia in 2010?
Offer a very short reply. 0.02. What is the average Revenue generated (in %) of Central Europe per year?
Make the answer very short. 0.54. What is the average Revenue generated (in %) of Iceland per year?
Offer a terse response. 3.16. What is the average Revenue generated (in %) in Slovenia per year?
Offer a very short reply. 2.42. What is the average Revenue generated (in %) of Zambia per year?
Your answer should be very brief. 0.19. In the year 2003, what is the difference between the Revenue generated (in %) in Central Europe and Revenue generated (in %) in Iceland?
Offer a very short reply. -2.99. In the year 2003, what is the difference between the Revenue generated (in %) in Central Europe and Revenue generated (in %) in Slovenia?
Give a very brief answer. -3.04. In the year 2003, what is the difference between the Revenue generated (in %) in Central Europe and Revenue generated (in %) in Zambia?
Your answer should be compact. 0.45. In the year 2003, what is the difference between the Revenue generated (in %) in Iceland and Revenue generated (in %) in Slovenia?
Ensure brevity in your answer.  -0.06. In the year 2003, what is the difference between the Revenue generated (in %) of Iceland and Revenue generated (in %) of Zambia?
Offer a very short reply. 3.44. In the year 2003, what is the difference between the Revenue generated (in %) of Slovenia and Revenue generated (in %) of Zambia?
Your response must be concise. 3.5. In the year 2004, what is the difference between the Revenue generated (in %) of Central Europe and Revenue generated (in %) of Iceland?
Ensure brevity in your answer.  -3.42. In the year 2004, what is the difference between the Revenue generated (in %) in Central Europe and Revenue generated (in %) in Slovenia?
Your answer should be compact. -3.45. In the year 2004, what is the difference between the Revenue generated (in %) in Central Europe and Revenue generated (in %) in Zambia?
Your response must be concise. 0.5. In the year 2004, what is the difference between the Revenue generated (in %) in Iceland and Revenue generated (in %) in Slovenia?
Offer a very short reply. -0.04. In the year 2004, what is the difference between the Revenue generated (in %) in Iceland and Revenue generated (in %) in Zambia?
Your answer should be very brief. 3.92. In the year 2004, what is the difference between the Revenue generated (in %) of Slovenia and Revenue generated (in %) of Zambia?
Keep it short and to the point. 3.95. In the year 2005, what is the difference between the Revenue generated (in %) of Central Europe and Revenue generated (in %) of Iceland?
Your response must be concise. -3.14. In the year 2005, what is the difference between the Revenue generated (in %) of Central Europe and Revenue generated (in %) of Slovenia?
Make the answer very short. -3.01. In the year 2005, what is the difference between the Revenue generated (in %) of Central Europe and Revenue generated (in %) of Zambia?
Your response must be concise. 0.63. In the year 2005, what is the difference between the Revenue generated (in %) in Iceland and Revenue generated (in %) in Slovenia?
Keep it short and to the point. 0.14. In the year 2005, what is the difference between the Revenue generated (in %) in Iceland and Revenue generated (in %) in Zambia?
Ensure brevity in your answer.  3.77. In the year 2005, what is the difference between the Revenue generated (in %) of Slovenia and Revenue generated (in %) of Zambia?
Give a very brief answer. 3.63. In the year 2006, what is the difference between the Revenue generated (in %) in Central Europe and Revenue generated (in %) in Iceland?
Keep it short and to the point. -1.68. In the year 2006, what is the difference between the Revenue generated (in %) in Central Europe and Revenue generated (in %) in Slovenia?
Your response must be concise. -2.53. In the year 2006, what is the difference between the Revenue generated (in %) of Central Europe and Revenue generated (in %) of Zambia?
Provide a succinct answer. 0.44. In the year 2006, what is the difference between the Revenue generated (in %) in Iceland and Revenue generated (in %) in Slovenia?
Offer a very short reply. -0.85. In the year 2006, what is the difference between the Revenue generated (in %) of Iceland and Revenue generated (in %) of Zambia?
Your answer should be compact. 2.12. In the year 2006, what is the difference between the Revenue generated (in %) in Slovenia and Revenue generated (in %) in Zambia?
Offer a terse response. 2.97. In the year 2007, what is the difference between the Revenue generated (in %) of Central Europe and Revenue generated (in %) of Iceland?
Ensure brevity in your answer.  -2.41. In the year 2007, what is the difference between the Revenue generated (in %) in Central Europe and Revenue generated (in %) in Slovenia?
Make the answer very short. -2.12. In the year 2007, what is the difference between the Revenue generated (in %) of Central Europe and Revenue generated (in %) of Zambia?
Provide a succinct answer. 0.32. In the year 2007, what is the difference between the Revenue generated (in %) of Iceland and Revenue generated (in %) of Slovenia?
Ensure brevity in your answer.  0.29. In the year 2007, what is the difference between the Revenue generated (in %) in Iceland and Revenue generated (in %) in Zambia?
Keep it short and to the point. 2.73. In the year 2007, what is the difference between the Revenue generated (in %) of Slovenia and Revenue generated (in %) of Zambia?
Provide a succinct answer. 2.44. In the year 2008, what is the difference between the Revenue generated (in %) of Central Europe and Revenue generated (in %) of Iceland?
Keep it short and to the point. -1.7. In the year 2008, what is the difference between the Revenue generated (in %) in Central Europe and Revenue generated (in %) in Slovenia?
Your response must be concise. -0.98. In the year 2008, what is the difference between the Revenue generated (in %) in Central Europe and Revenue generated (in %) in Zambia?
Your answer should be compact. 0.31. In the year 2008, what is the difference between the Revenue generated (in %) in Iceland and Revenue generated (in %) in Slovenia?
Your response must be concise. 0.72. In the year 2008, what is the difference between the Revenue generated (in %) in Iceland and Revenue generated (in %) in Zambia?
Keep it short and to the point. 2.01. In the year 2008, what is the difference between the Revenue generated (in %) of Slovenia and Revenue generated (in %) of Zambia?
Ensure brevity in your answer.  1.29. In the year 2009, what is the difference between the Revenue generated (in %) of Central Europe and Revenue generated (in %) of Iceland?
Ensure brevity in your answer.  -2.54. In the year 2009, what is the difference between the Revenue generated (in %) in Central Europe and Revenue generated (in %) in Slovenia?
Ensure brevity in your answer.  -0.01. In the year 2009, what is the difference between the Revenue generated (in %) of Central Europe and Revenue generated (in %) of Zambia?
Make the answer very short. 0.05. In the year 2009, what is the difference between the Revenue generated (in %) of Iceland and Revenue generated (in %) of Slovenia?
Ensure brevity in your answer.  2.53. In the year 2009, what is the difference between the Revenue generated (in %) of Iceland and Revenue generated (in %) of Zambia?
Make the answer very short. 2.6. In the year 2009, what is the difference between the Revenue generated (in %) in Slovenia and Revenue generated (in %) in Zambia?
Provide a succinct answer. 0.06. In the year 2010, what is the difference between the Revenue generated (in %) of Central Europe and Revenue generated (in %) of Iceland?
Offer a very short reply. -3.12. In the year 2010, what is the difference between the Revenue generated (in %) of Central Europe and Revenue generated (in %) of Slovenia?
Keep it short and to the point. 0.05. In the year 2010, what is the difference between the Revenue generated (in %) of Central Europe and Revenue generated (in %) of Zambia?
Ensure brevity in your answer.  0.05. In the year 2010, what is the difference between the Revenue generated (in %) of Iceland and Revenue generated (in %) of Slovenia?
Provide a succinct answer. 3.17. In the year 2010, what is the difference between the Revenue generated (in %) of Iceland and Revenue generated (in %) of Zambia?
Your answer should be compact. 3.17. In the year 2010, what is the difference between the Revenue generated (in %) in Slovenia and Revenue generated (in %) in Zambia?
Offer a terse response. 0. What is the ratio of the Revenue generated (in %) of Central Europe in 2003 to that in 2004?
Give a very brief answer. 0.94. What is the ratio of the Revenue generated (in %) of Iceland in 2003 to that in 2004?
Your answer should be very brief. 0.88. What is the ratio of the Revenue generated (in %) of Slovenia in 2003 to that in 2004?
Offer a very short reply. 0.89. What is the ratio of the Revenue generated (in %) of Zambia in 2003 to that in 2004?
Offer a very short reply. 1.05. What is the ratio of the Revenue generated (in %) of Central Europe in 2003 to that in 2005?
Provide a short and direct response. 0.8. What is the ratio of the Revenue generated (in %) of Iceland in 2003 to that in 2005?
Provide a succinct answer. 0.92. What is the ratio of the Revenue generated (in %) in Slovenia in 2003 to that in 2005?
Make the answer very short. 0.97. What is the ratio of the Revenue generated (in %) of Zambia in 2003 to that in 2005?
Your answer should be very brief. 1.12. What is the ratio of the Revenue generated (in %) of Central Europe in 2003 to that in 2006?
Offer a very short reply. 0.94. What is the ratio of the Revenue generated (in %) of Iceland in 2003 to that in 2006?
Give a very brief answer. 1.54. What is the ratio of the Revenue generated (in %) in Slovenia in 2003 to that in 2006?
Offer a very short reply. 1.15. What is the ratio of the Revenue generated (in %) in Zambia in 2003 to that in 2006?
Offer a terse response. 0.75. What is the ratio of the Revenue generated (in %) of Central Europe in 2003 to that in 2007?
Offer a terse response. 1.13. What is the ratio of the Revenue generated (in %) in Iceland in 2003 to that in 2007?
Ensure brevity in your answer.  1.22. What is the ratio of the Revenue generated (in %) in Slovenia in 2003 to that in 2007?
Provide a short and direct response. 1.37. What is the ratio of the Revenue generated (in %) of Zambia in 2003 to that in 2007?
Make the answer very short. 0.73. What is the ratio of the Revenue generated (in %) of Central Europe in 2003 to that in 2008?
Give a very brief answer. 1.2. What is the ratio of the Revenue generated (in %) in Iceland in 2003 to that in 2008?
Your answer should be very brief. 1.63. What is the ratio of the Revenue generated (in %) of Slovenia in 2003 to that in 2008?
Provide a succinct answer. 2.45. What is the ratio of the Revenue generated (in %) in Zambia in 2003 to that in 2008?
Ensure brevity in your answer.  0.83. What is the ratio of the Revenue generated (in %) in Central Europe in 2003 to that in 2009?
Ensure brevity in your answer.  2.67. What is the ratio of the Revenue generated (in %) in Iceland in 2003 to that in 2009?
Your answer should be compact. 1.3. What is the ratio of the Revenue generated (in %) of Slovenia in 2003 to that in 2009?
Provide a succinct answer. 15.14. What is the ratio of the Revenue generated (in %) in Zambia in 2003 to that in 2009?
Keep it short and to the point. 0.95. What is the ratio of the Revenue generated (in %) in Central Europe in 2003 to that in 2010?
Keep it short and to the point. 2.28. What is the ratio of the Revenue generated (in %) in Iceland in 2003 to that in 2010?
Make the answer very short. 1.06. What is the ratio of the Revenue generated (in %) of Slovenia in 2003 to that in 2010?
Give a very brief answer. 16.17. What is the ratio of the Revenue generated (in %) in Zambia in 2003 to that in 2010?
Your response must be concise. 0.76. What is the ratio of the Revenue generated (in %) in Central Europe in 2004 to that in 2005?
Give a very brief answer. 0.85. What is the ratio of the Revenue generated (in %) in Iceland in 2004 to that in 2005?
Keep it short and to the point. 1.04. What is the ratio of the Revenue generated (in %) in Slovenia in 2004 to that in 2005?
Offer a terse response. 1.09. What is the ratio of the Revenue generated (in %) of Zambia in 2004 to that in 2005?
Your answer should be very brief. 1.07. What is the ratio of the Revenue generated (in %) of Iceland in 2004 to that in 2006?
Your response must be concise. 1.74. What is the ratio of the Revenue generated (in %) in Slovenia in 2004 to that in 2006?
Provide a short and direct response. 1.29. What is the ratio of the Revenue generated (in %) in Zambia in 2004 to that in 2006?
Provide a short and direct response. 0.71. What is the ratio of the Revenue generated (in %) of Central Europe in 2004 to that in 2007?
Your answer should be compact. 1.21. What is the ratio of the Revenue generated (in %) in Iceland in 2004 to that in 2007?
Make the answer very short. 1.38. What is the ratio of the Revenue generated (in %) in Slovenia in 2004 to that in 2007?
Provide a succinct answer. 1.54. What is the ratio of the Revenue generated (in %) of Zambia in 2004 to that in 2007?
Keep it short and to the point. 0.7. What is the ratio of the Revenue generated (in %) of Central Europe in 2004 to that in 2008?
Offer a very short reply. 1.28. What is the ratio of the Revenue generated (in %) in Iceland in 2004 to that in 2008?
Keep it short and to the point. 1.84. What is the ratio of the Revenue generated (in %) of Slovenia in 2004 to that in 2008?
Your answer should be compact. 2.74. What is the ratio of the Revenue generated (in %) of Zambia in 2004 to that in 2008?
Provide a short and direct response. 0.79. What is the ratio of the Revenue generated (in %) of Central Europe in 2004 to that in 2009?
Ensure brevity in your answer.  2.84. What is the ratio of the Revenue generated (in %) in Iceland in 2004 to that in 2009?
Your answer should be compact. 1.47. What is the ratio of the Revenue generated (in %) in Slovenia in 2004 to that in 2009?
Your answer should be very brief. 17. What is the ratio of the Revenue generated (in %) in Zambia in 2004 to that in 2009?
Offer a very short reply. 0.9. What is the ratio of the Revenue generated (in %) in Central Europe in 2004 to that in 2010?
Offer a very short reply. 2.43. What is the ratio of the Revenue generated (in %) in Iceland in 2004 to that in 2010?
Offer a terse response. 1.2. What is the ratio of the Revenue generated (in %) in Slovenia in 2004 to that in 2010?
Your response must be concise. 18.14. What is the ratio of the Revenue generated (in %) of Zambia in 2004 to that in 2010?
Make the answer very short. 0.72. What is the ratio of the Revenue generated (in %) of Central Europe in 2005 to that in 2006?
Give a very brief answer. 1.18. What is the ratio of the Revenue generated (in %) in Iceland in 2005 to that in 2006?
Your response must be concise. 1.67. What is the ratio of the Revenue generated (in %) of Slovenia in 2005 to that in 2006?
Your answer should be compact. 1.19. What is the ratio of the Revenue generated (in %) in Zambia in 2005 to that in 2006?
Offer a terse response. 0.67. What is the ratio of the Revenue generated (in %) in Central Europe in 2005 to that in 2007?
Keep it short and to the point. 1.42. What is the ratio of the Revenue generated (in %) in Iceland in 2005 to that in 2007?
Offer a terse response. 1.32. What is the ratio of the Revenue generated (in %) in Slovenia in 2005 to that in 2007?
Your answer should be very brief. 1.42. What is the ratio of the Revenue generated (in %) of Zambia in 2005 to that in 2007?
Offer a very short reply. 0.65. What is the ratio of the Revenue generated (in %) in Central Europe in 2005 to that in 2008?
Make the answer very short. 1.5. What is the ratio of the Revenue generated (in %) of Iceland in 2005 to that in 2008?
Your answer should be compact. 1.77. What is the ratio of the Revenue generated (in %) in Slovenia in 2005 to that in 2008?
Your response must be concise. 2.53. What is the ratio of the Revenue generated (in %) in Zambia in 2005 to that in 2008?
Keep it short and to the point. 0.74. What is the ratio of the Revenue generated (in %) of Central Europe in 2005 to that in 2009?
Make the answer very short. 3.35. What is the ratio of the Revenue generated (in %) in Iceland in 2005 to that in 2009?
Give a very brief answer. 1.41. What is the ratio of the Revenue generated (in %) in Slovenia in 2005 to that in 2009?
Your answer should be very brief. 15.64. What is the ratio of the Revenue generated (in %) of Zambia in 2005 to that in 2009?
Give a very brief answer. 0.85. What is the ratio of the Revenue generated (in %) of Central Europe in 2005 to that in 2010?
Give a very brief answer. 2.86. What is the ratio of the Revenue generated (in %) in Iceland in 2005 to that in 2010?
Your answer should be very brief. 1.16. What is the ratio of the Revenue generated (in %) in Slovenia in 2005 to that in 2010?
Offer a very short reply. 16.7. What is the ratio of the Revenue generated (in %) in Zambia in 2005 to that in 2010?
Give a very brief answer. 0.67. What is the ratio of the Revenue generated (in %) in Central Europe in 2006 to that in 2007?
Your answer should be compact. 1.21. What is the ratio of the Revenue generated (in %) of Iceland in 2006 to that in 2007?
Make the answer very short. 0.79. What is the ratio of the Revenue generated (in %) of Slovenia in 2006 to that in 2007?
Offer a very short reply. 1.2. What is the ratio of the Revenue generated (in %) of Zambia in 2006 to that in 2007?
Provide a short and direct response. 0.97. What is the ratio of the Revenue generated (in %) of Central Europe in 2006 to that in 2008?
Ensure brevity in your answer.  1.28. What is the ratio of the Revenue generated (in %) in Iceland in 2006 to that in 2008?
Your answer should be very brief. 1.06. What is the ratio of the Revenue generated (in %) of Slovenia in 2006 to that in 2008?
Your response must be concise. 2.13. What is the ratio of the Revenue generated (in %) in Zambia in 2006 to that in 2008?
Provide a short and direct response. 1.1. What is the ratio of the Revenue generated (in %) in Central Europe in 2006 to that in 2009?
Offer a very short reply. 2.85. What is the ratio of the Revenue generated (in %) in Iceland in 2006 to that in 2009?
Give a very brief answer. 0.84. What is the ratio of the Revenue generated (in %) in Slovenia in 2006 to that in 2009?
Provide a short and direct response. 13.2. What is the ratio of the Revenue generated (in %) in Zambia in 2006 to that in 2009?
Make the answer very short. 1.26. What is the ratio of the Revenue generated (in %) of Central Europe in 2006 to that in 2010?
Ensure brevity in your answer.  2.43. What is the ratio of the Revenue generated (in %) of Iceland in 2006 to that in 2010?
Your response must be concise. 0.69. What is the ratio of the Revenue generated (in %) in Slovenia in 2006 to that in 2010?
Provide a succinct answer. 14.09. What is the ratio of the Revenue generated (in %) in Central Europe in 2007 to that in 2008?
Offer a terse response. 1.06. What is the ratio of the Revenue generated (in %) of Iceland in 2007 to that in 2008?
Offer a very short reply. 1.33. What is the ratio of the Revenue generated (in %) of Slovenia in 2007 to that in 2008?
Your answer should be very brief. 1.78. What is the ratio of the Revenue generated (in %) in Zambia in 2007 to that in 2008?
Ensure brevity in your answer.  1.13. What is the ratio of the Revenue generated (in %) of Central Europe in 2007 to that in 2009?
Give a very brief answer. 2.35. What is the ratio of the Revenue generated (in %) in Iceland in 2007 to that in 2009?
Offer a terse response. 1.07. What is the ratio of the Revenue generated (in %) of Slovenia in 2007 to that in 2009?
Make the answer very short. 11.02. What is the ratio of the Revenue generated (in %) in Zambia in 2007 to that in 2009?
Your response must be concise. 1.3. What is the ratio of the Revenue generated (in %) of Central Europe in 2007 to that in 2010?
Make the answer very short. 2.01. What is the ratio of the Revenue generated (in %) in Iceland in 2007 to that in 2010?
Provide a succinct answer. 0.87. What is the ratio of the Revenue generated (in %) of Slovenia in 2007 to that in 2010?
Provide a short and direct response. 11.76. What is the ratio of the Revenue generated (in %) in Zambia in 2007 to that in 2010?
Your response must be concise. 1.03. What is the ratio of the Revenue generated (in %) in Central Europe in 2008 to that in 2009?
Provide a short and direct response. 2.23. What is the ratio of the Revenue generated (in %) of Iceland in 2008 to that in 2009?
Your answer should be compact. 0.8. What is the ratio of the Revenue generated (in %) of Slovenia in 2008 to that in 2009?
Ensure brevity in your answer.  6.19. What is the ratio of the Revenue generated (in %) of Zambia in 2008 to that in 2009?
Your response must be concise. 1.15. What is the ratio of the Revenue generated (in %) of Central Europe in 2008 to that in 2010?
Offer a very short reply. 1.9. What is the ratio of the Revenue generated (in %) in Iceland in 2008 to that in 2010?
Make the answer very short. 0.65. What is the ratio of the Revenue generated (in %) in Slovenia in 2008 to that in 2010?
Your response must be concise. 6.61. What is the ratio of the Revenue generated (in %) in Zambia in 2008 to that in 2010?
Make the answer very short. 0.92. What is the ratio of the Revenue generated (in %) in Central Europe in 2009 to that in 2010?
Your response must be concise. 0.85. What is the ratio of the Revenue generated (in %) of Iceland in 2009 to that in 2010?
Your answer should be very brief. 0.82. What is the ratio of the Revenue generated (in %) of Slovenia in 2009 to that in 2010?
Provide a short and direct response. 1.07. What is the ratio of the Revenue generated (in %) of Zambia in 2009 to that in 2010?
Provide a succinct answer. 0.79. What is the difference between the highest and the second highest Revenue generated (in %) of Central Europe?
Ensure brevity in your answer.  0.12. What is the difference between the highest and the second highest Revenue generated (in %) of Iceland?
Your answer should be compact. 0.16. What is the difference between the highest and the second highest Revenue generated (in %) of Slovenia?
Give a very brief answer. 0.33. What is the difference between the highest and the second highest Revenue generated (in %) in Zambia?
Your response must be concise. 0.01. What is the difference between the highest and the lowest Revenue generated (in %) in Central Europe?
Your answer should be compact. 0.55. What is the difference between the highest and the lowest Revenue generated (in %) of Iceland?
Offer a very short reply. 1.86. What is the difference between the highest and the lowest Revenue generated (in %) in Slovenia?
Your answer should be compact. 3.89. What is the difference between the highest and the lowest Revenue generated (in %) in Zambia?
Provide a short and direct response. 0.08. 